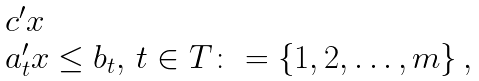Convert formula to latex. <formula><loc_0><loc_0><loc_500><loc_500>\begin{array} { l l } & c ^ { \prime } x \\ & a _ { t } ^ { \prime } x \leq b _ { t } , \, t \in T \colon = \left \{ 1 , 2 , \dots , m \right \} , \end{array}</formula> 